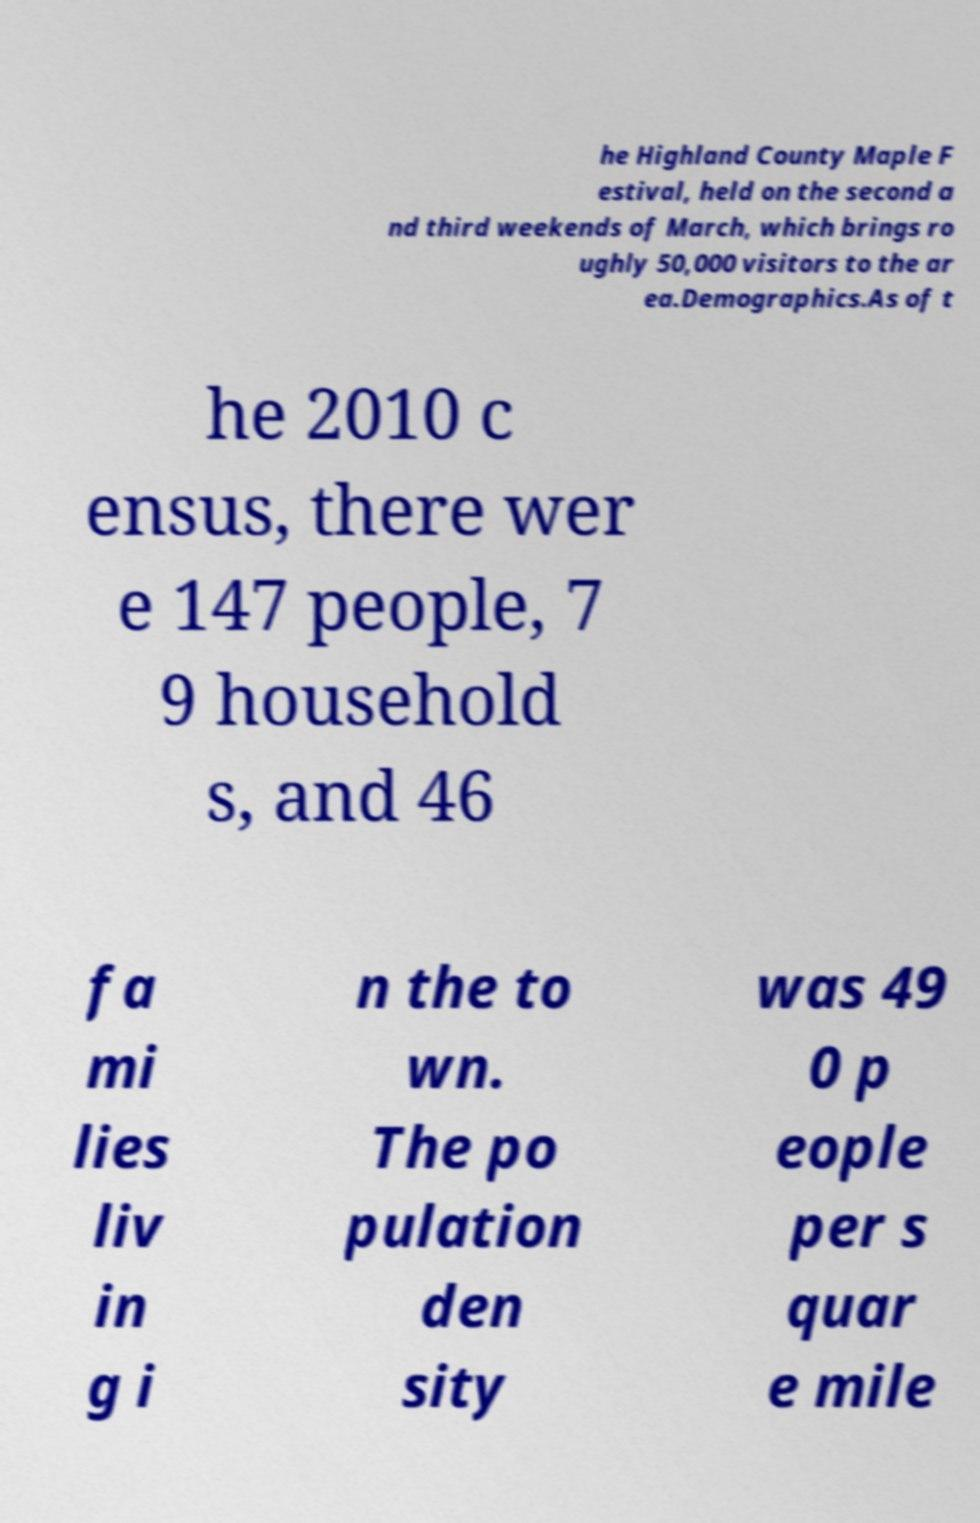For documentation purposes, I need the text within this image transcribed. Could you provide that? he Highland County Maple F estival, held on the second a nd third weekends of March, which brings ro ughly 50,000 visitors to the ar ea.Demographics.As of t he 2010 c ensus, there wer e 147 people, 7 9 household s, and 46 fa mi lies liv in g i n the to wn. The po pulation den sity was 49 0 p eople per s quar e mile 